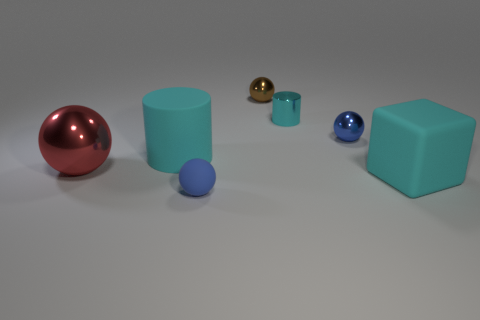What color is the tiny object that is in front of the shiny object to the left of the big cyan object to the left of the big cyan block?
Provide a succinct answer. Blue. Is there a small red rubber object that has the same shape as the big metallic object?
Keep it short and to the point. No. There is a cube that is the same size as the red shiny sphere; what color is it?
Your response must be concise. Cyan. There is a tiny ball on the left side of the brown metal ball; what is its material?
Make the answer very short. Rubber. Is the shape of the big cyan object that is on the right side of the brown metallic object the same as the large matte object left of the cyan metal object?
Your answer should be very brief. No. Are there an equal number of tiny objects that are in front of the large metallic sphere and cylinders?
Keep it short and to the point. No. How many balls are made of the same material as the large cube?
Ensure brevity in your answer.  1. What color is the large object that is the same material as the tiny cyan thing?
Your answer should be very brief. Red. Does the rubber ball have the same size as the blue ball on the right side of the tiny brown metallic ball?
Provide a succinct answer. Yes. What is the shape of the small cyan thing?
Make the answer very short. Cylinder. 